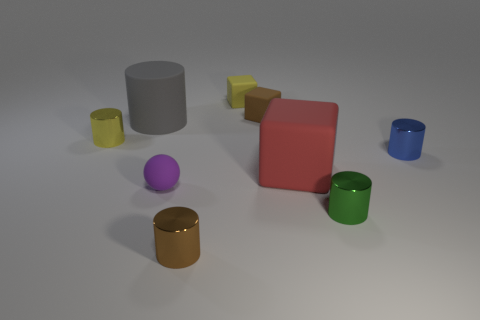What number of things have the same size as the brown cylinder? There are six objects that share the same size with the brown cylinder, each varying in color and positioned at different angles in the scene. 